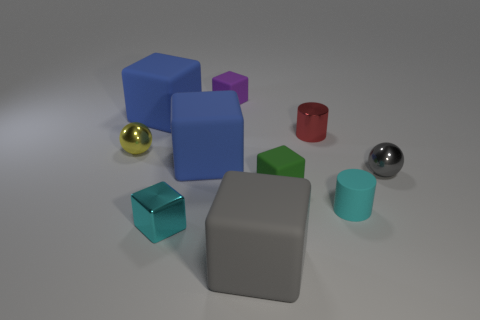Subtract all blue blocks. How many blocks are left? 4 Subtract all gray blocks. How many blocks are left? 5 Subtract all cyan blocks. Subtract all blue spheres. How many blocks are left? 5 Subtract all cylinders. How many objects are left? 8 Add 9 shiny blocks. How many shiny blocks exist? 10 Subtract 0 purple balls. How many objects are left? 10 Subtract all small brown shiny balls. Subtract all cyan cylinders. How many objects are left? 9 Add 9 green blocks. How many green blocks are left? 10 